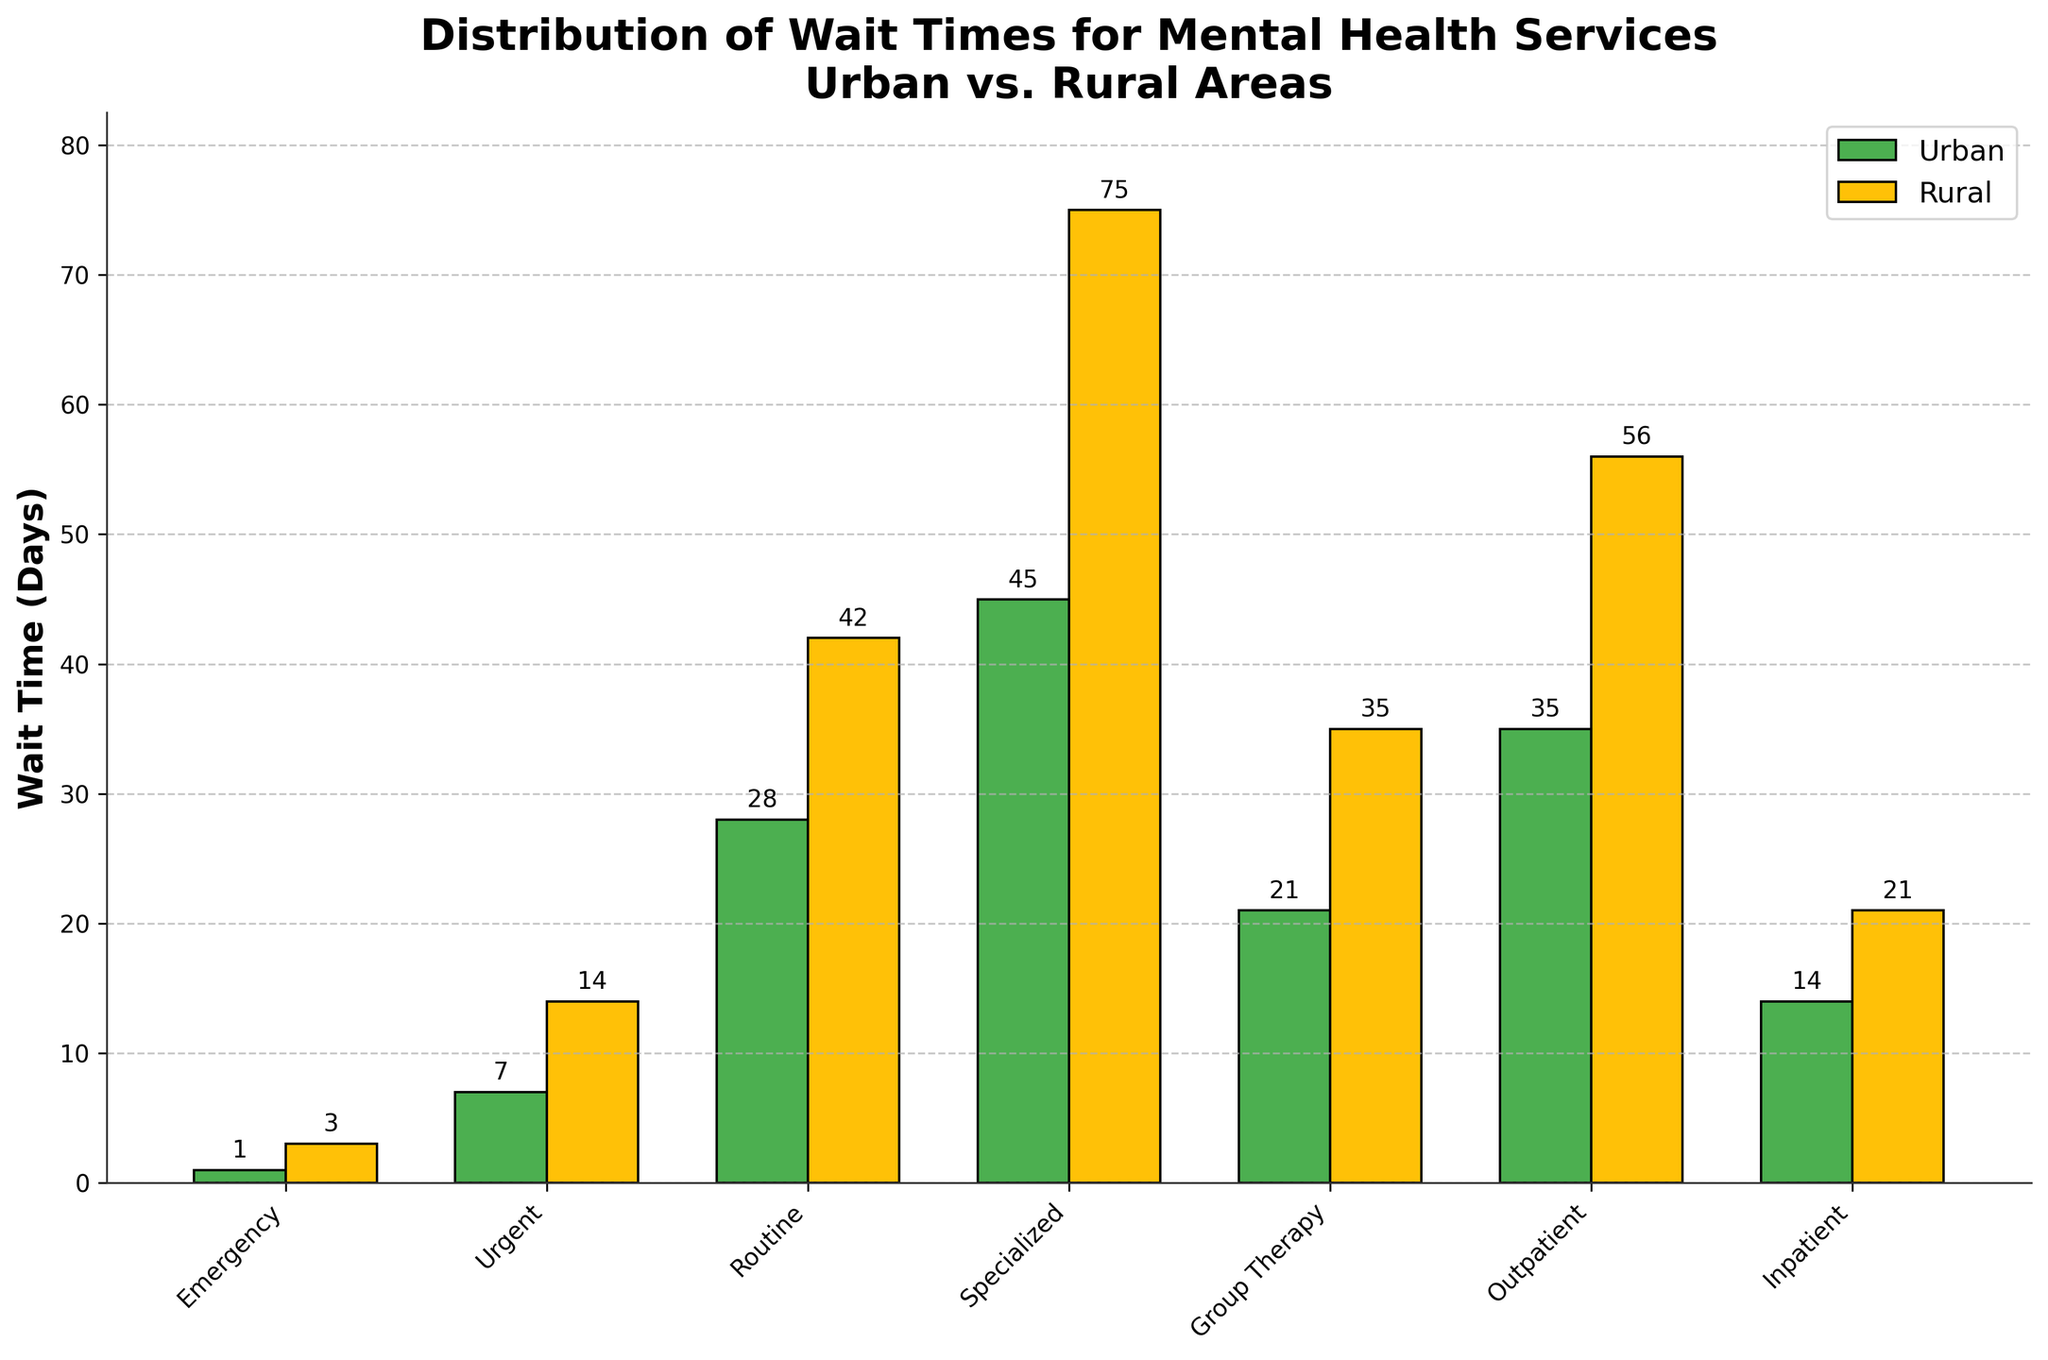What's the wait time for emergency mental health services in rural areas? The wait time for emergency mental health services in rural areas is represented by the height of the leftmost yellow bar. It is labeled with the value.
Answer: 3 days Which area has a longer wait time for specialized mental health services, urban or rural? Compare the heights of the two bars labeled "Specialized". The yellow bar representing rural areas is taller than the green bar representing urban areas. The value for rural areas is also higher.
Answer: Rural By how many days is the wait time for outpatient services longer in rural areas compared to urban areas? Check the heights of the bars labeled "Outpatient". The rural wait time is 56 days (yellow bar) and the urban wait time is 35 days (green bar). Subtract the urban wait time from the rural wait time (56 - 35).
Answer: 21 days What is the average wait time for urgent mental health services in both urban and rural areas? Identify the wait times from the bars labeled "Urgent". Urban is 7 days (green bar) and rural is 14 days (yellow bar). Sum these values and then divide by 2 to get the average (7 + 14) / 2.
Answer: 10.5 days Is the wait time for mental health services shorter in urban areas compared to rural areas for all types of services? Compare the heights of the corresponding bars for each type of service. For emergency, urgent, routine, specialized, group therapy, outpatient, and inpatient services, the yellow bars (rural) are always taller than or equal to the green bars (urban).
Answer: Yes What's the difference in wait times for routine mental health services between urban and rural areas? Compare the heights of the bars labeled "Routine". The urban wait time is 28 days (green bar) and the rural wait time is 42 days (yellow bar). Subtract the urban wait time from the rural wait time (42 - 28).
Answer: 14 days Which type of service has the longest wait time in rural areas? Identify the tallest yellow bar, which represents rural areas. The tallest bar corresponds to "Specialized" services.
Answer: Specialized For which type of mental health service is the wait time equal between urban and rural areas? Compare the heights of corresponding bars in both colors. The bars for "Inpatient" services are equal in height.
Answer: Inpatient What is the total wait time for all mental health services combined in urban areas? Sum the wait times for all urban services: 1 (Emergency) + 7 (Urgent) + 28 (Routine) + 45 (Specialized) + 21 (Group Therapy) + 35 (Outpatient) + 14 (Inpatient).
Answer: 151 days What pattern do you observe in the difference between urban and rural wait times across various services? For each type of service, rural wait times are consistently longer than urban wait times. This pattern is visually represented by the yellow bars being taller than the green bars for each service category.
Answer: Rural wait times are longer 